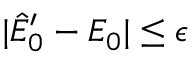Convert formula to latex. <formula><loc_0><loc_0><loc_500><loc_500>| \hat { E } _ { 0 } ^ { \prime } - E _ { 0 } | \leq \epsilon</formula> 